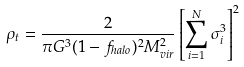Convert formula to latex. <formula><loc_0><loc_0><loc_500><loc_500>\rho _ { t } = \frac { 2 } { \pi G ^ { 3 } ( 1 - f _ { h a l o } ) ^ { 2 } M _ { v i r } ^ { 2 } } \left [ \sum _ { i = 1 } ^ { N } \sigma _ { i } ^ { 3 } \right ] ^ { 2 }</formula> 